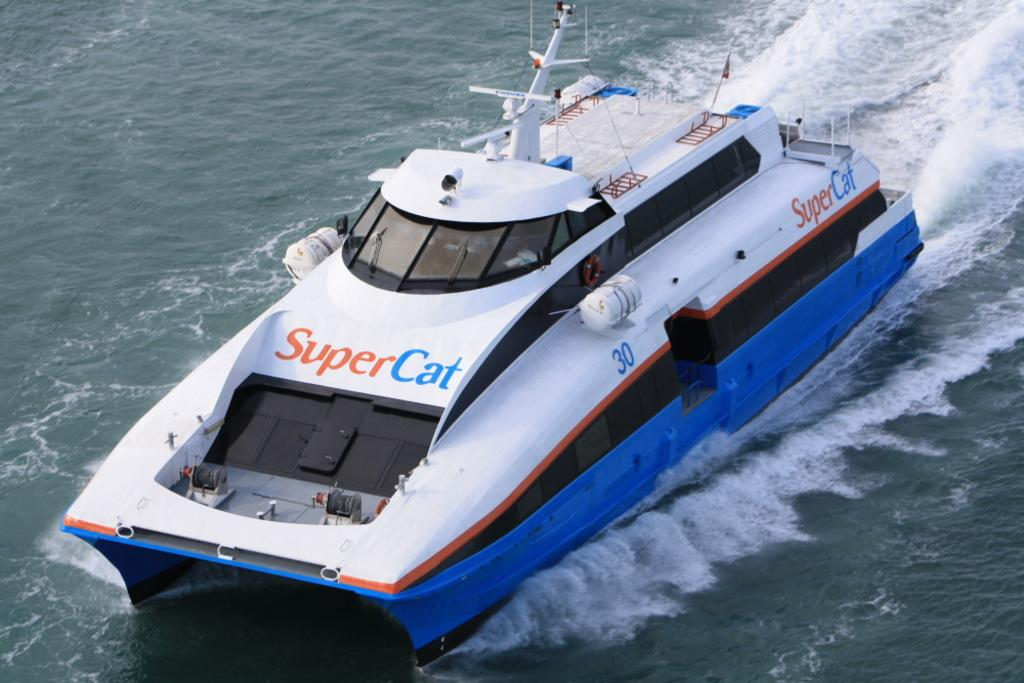What is the primary element in the image? There is water in the image. What can be seen floating on the water? There is a white and blue color boat in the water. What is unique about the boat? There is writing on the boat. What type of chin can be seen on the boat in the image? There is no chin present on the boat in the image, as it is an inanimate object. 